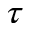Convert formula to latex. <formula><loc_0><loc_0><loc_500><loc_500>\tau</formula> 